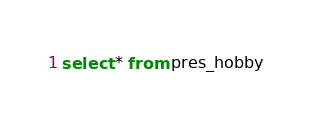<code> <loc_0><loc_0><loc_500><loc_500><_SQL_>select * from pres_hobby</code> 